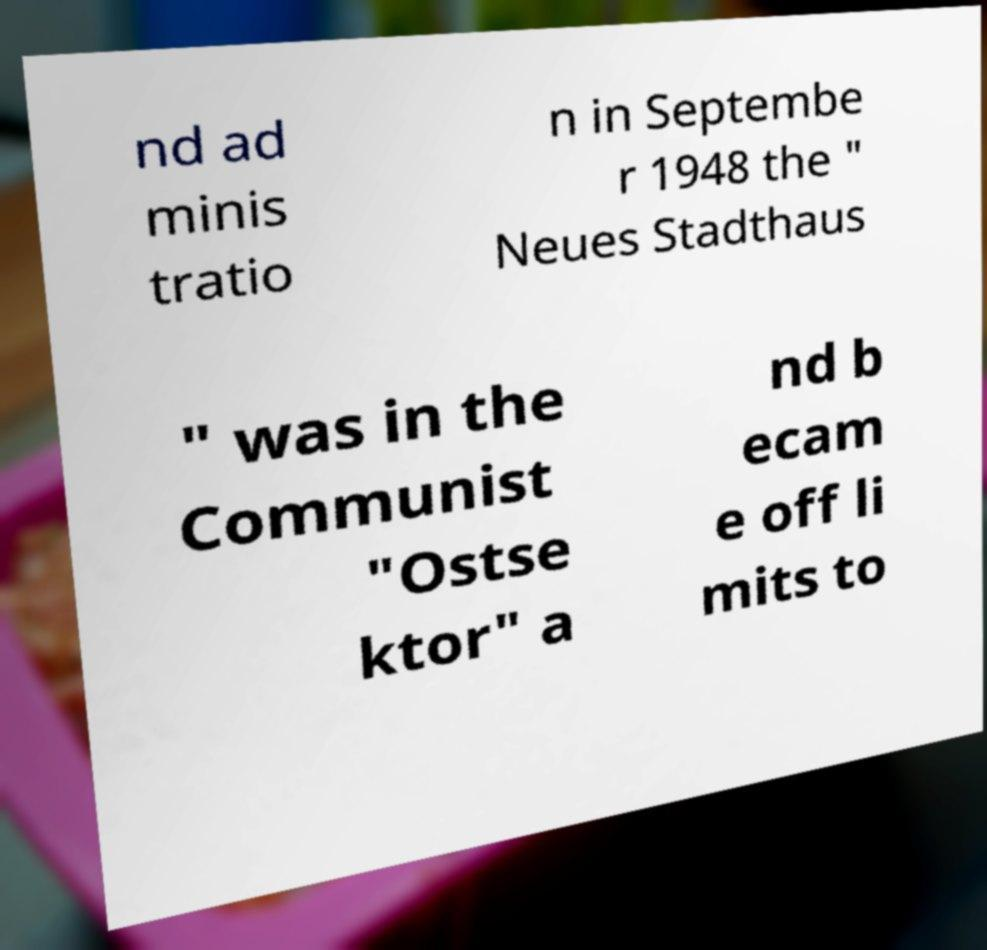I need the written content from this picture converted into text. Can you do that? nd ad minis tratio n in Septembe r 1948 the " Neues Stadthaus " was in the Communist "Ostse ktor" a nd b ecam e off li mits to 